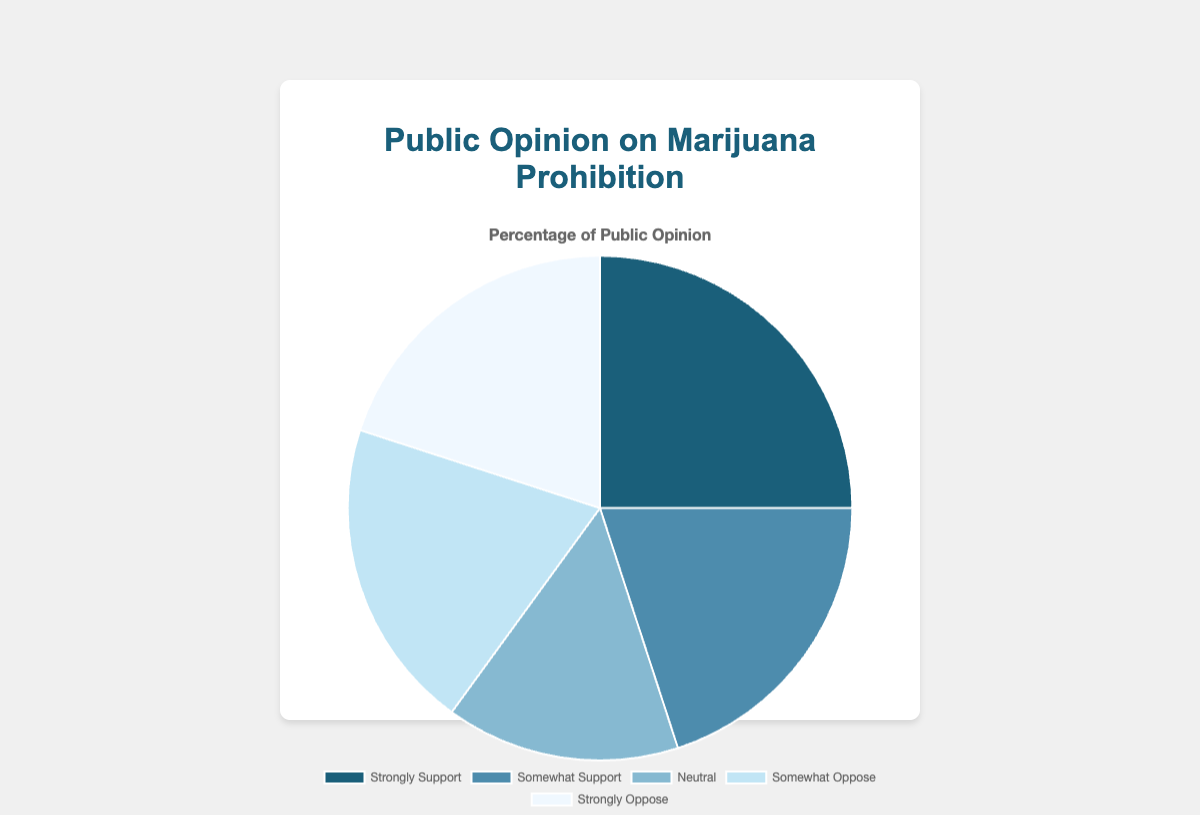What is the most supported opinion on marijuana prohibition according to the chart? The "Strongly Support" section has the highest percentage with 25% as indicated by the largest slice of the pie chart.
Answer: Strongly Support Which two opinions are equally supported by the public? According to the pie chart, "Somewhat Support," "Somewhat Oppose," and "Strongly Oppose" each account for 20% of the public opinion, showing equal support.
Answer: Somewhat Support, Somewhat Oppose, Strongly Oppose What percentage of people either somewhat support or somewhat oppose marijuana prohibition? The pie chart shows "Somewhat Support" with 20% and "Somewhat Oppose" with 20%. Adding these percentages gives 20% + 20% = 40%.
Answer: 40% How does the percentage of people who are neutral compare to those who strongly oppose marijuana prohibition? The pie chart indicates that 15% are neutral and 20% strongly oppose. Therefore, the group that strongly opposes is larger by 5%.
Answer: Strongly Oppose by 5% What is the total percentage of people who either strongly support or strongly oppose marijuana prohibition? The pie chart shows that 25% strongly support and 20% strongly oppose. Adding these percentages gives 25% + 20% = 45%.
Answer: 45% Which opinion has the smallest percentage of public support? The "Neutral" category has the smallest percentage with 15%, as indicated by the smallest slice of the pie chart.
Answer: Neutral How does the combined support for prohibition (strongly and somewhat support) compare to the combined opposition (somewhat and strongly oppose)? The pie chart shows 25% strongly support and 20% somewhat support, combining to 45%. It also shows 20% somewhat oppose and 20% strongly oppose, combining to 40%. Therefore, combined support is higher by 5%.
Answer: Support is higher by 5% What are the combined percentages of all opinions that are either neutral or oppose marijuana prohibition? The pie chart indicates 15% are neutral, 20% somewhat oppose, and 20% strongly oppose. Adding these percentages gives 15% + 20% + 20% = 55%.
Answer: 55% How does the segment size for "Neutral" compare visually to "Strongly Support"? The pie chart shows that the "Neutral" segment is smaller compared to the "Strongly Support" segment, indicating less public opinion in the neutral category.
Answer: Neutral is smaller What is the average percentage of all public opinions on marijuana prohibition? There are 5 data points: 25%, 20%, 15%, 20%, and 20%. The sum of these percentages is 25% + 20% + 15% + 20% + 20% = 100%. Dividing by 5 gives an average of 100% / 5 = 20%.
Answer: 20% 